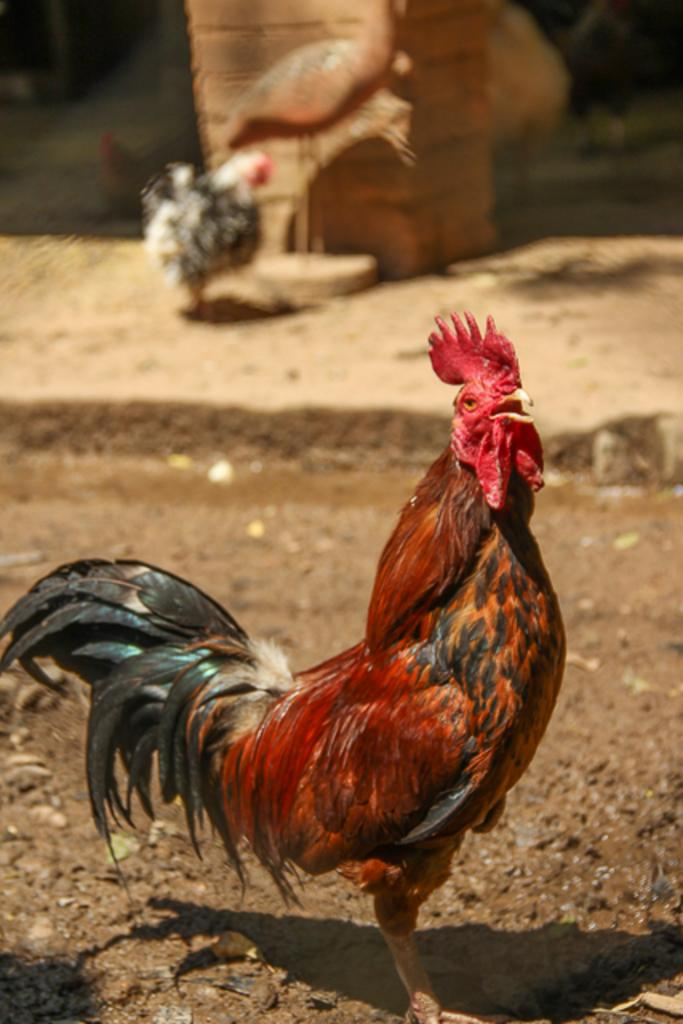What animal is the main subject of the image? There is a hen in the image. Can you describe the background of the image? The background of the image is blurry. Are there any other hens visible in the image? Yes, there are hens visible in the background. What type of teaching method is being used by the hen in the image? There is no teaching method being used by the hen in the image, as it is an animal and not capable of teaching. 